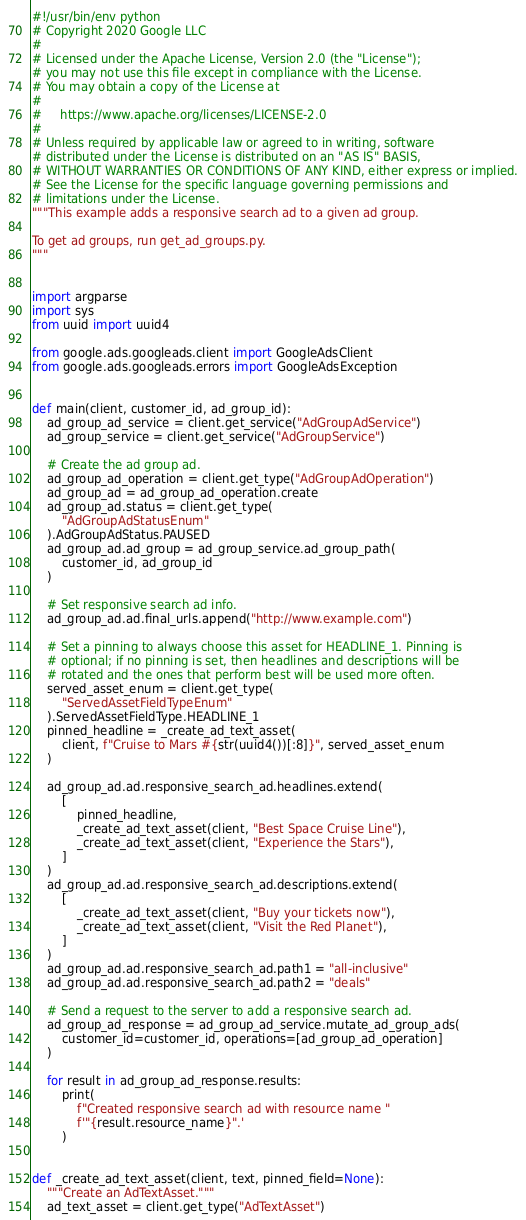<code> <loc_0><loc_0><loc_500><loc_500><_Python_>#!/usr/bin/env python
# Copyright 2020 Google LLC
#
# Licensed under the Apache License, Version 2.0 (the "License");
# you may not use this file except in compliance with the License.
# You may obtain a copy of the License at
#
#     https://www.apache.org/licenses/LICENSE-2.0
#
# Unless required by applicable law or agreed to in writing, software
# distributed under the License is distributed on an "AS IS" BASIS,
# WITHOUT WARRANTIES OR CONDITIONS OF ANY KIND, either express or implied.
# See the License for the specific language governing permissions and
# limitations under the License.
"""This example adds a responsive search ad to a given ad group.

To get ad groups, run get_ad_groups.py.
"""


import argparse
import sys
from uuid import uuid4

from google.ads.googleads.client import GoogleAdsClient
from google.ads.googleads.errors import GoogleAdsException


def main(client, customer_id, ad_group_id):
    ad_group_ad_service = client.get_service("AdGroupAdService")
    ad_group_service = client.get_service("AdGroupService")

    # Create the ad group ad.
    ad_group_ad_operation = client.get_type("AdGroupAdOperation")
    ad_group_ad = ad_group_ad_operation.create
    ad_group_ad.status = client.get_type(
        "AdGroupAdStatusEnum"
    ).AdGroupAdStatus.PAUSED
    ad_group_ad.ad_group = ad_group_service.ad_group_path(
        customer_id, ad_group_id
    )

    # Set responsive search ad info.
    ad_group_ad.ad.final_urls.append("http://www.example.com")

    # Set a pinning to always choose this asset for HEADLINE_1. Pinning is
    # optional; if no pinning is set, then headlines and descriptions will be
    # rotated and the ones that perform best will be used more often.
    served_asset_enum = client.get_type(
        "ServedAssetFieldTypeEnum"
    ).ServedAssetFieldType.HEADLINE_1
    pinned_headline = _create_ad_text_asset(
        client, f"Cruise to Mars #{str(uuid4())[:8]}", served_asset_enum
    )

    ad_group_ad.ad.responsive_search_ad.headlines.extend(
        [
            pinned_headline,
            _create_ad_text_asset(client, "Best Space Cruise Line"),
            _create_ad_text_asset(client, "Experience the Stars"),
        ]
    )
    ad_group_ad.ad.responsive_search_ad.descriptions.extend(
        [
            _create_ad_text_asset(client, "Buy your tickets now"),
            _create_ad_text_asset(client, "Visit the Red Planet"),
        ]
    )
    ad_group_ad.ad.responsive_search_ad.path1 = "all-inclusive"
    ad_group_ad.ad.responsive_search_ad.path2 = "deals"

    # Send a request to the server to add a responsive search ad.
    ad_group_ad_response = ad_group_ad_service.mutate_ad_group_ads(
        customer_id=customer_id, operations=[ad_group_ad_operation]
    )

    for result in ad_group_ad_response.results:
        print(
            f"Created responsive search ad with resource name "
            f'"{result.resource_name}".'
        )


def _create_ad_text_asset(client, text, pinned_field=None):
    """Create an AdTextAsset."""
    ad_text_asset = client.get_type("AdTextAsset")</code> 